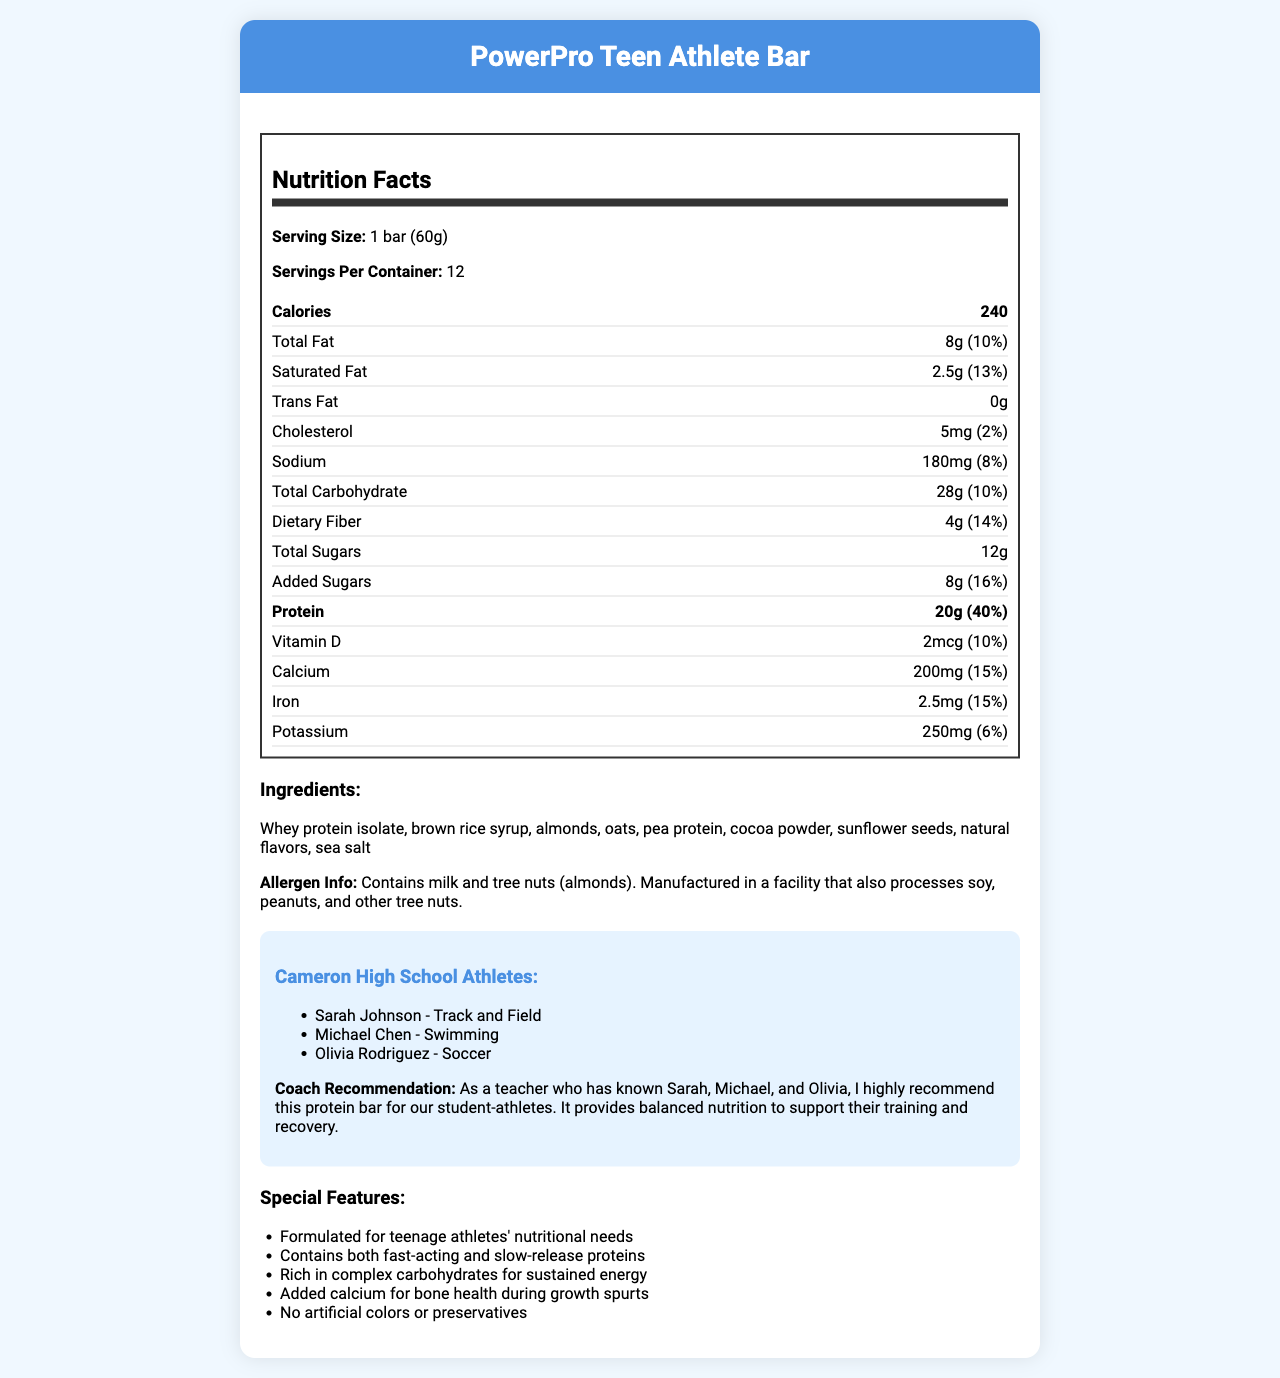what is the serving size of the PowerPro Teen Athlete Bar? The serving size is listed at the top of the nutrition label.
Answer: 1 bar (60g) how many calories are in one serving of the PowerPro Teen Athlete Bar? The calorie content per serving is mentioned directly in the Nutrition Facts section.
Answer: 240 how many grams of protein does the PowerPro Teen Athlete Bar contain? The protein content is specified in the nutrition facts under the section Protein.
Answer: 20g how many servings are in one container of the PowerPro Teen Athlete Bar? The servings per container information is provided at the beginning of the nutrition facts.
Answer: 12 name three camera high school athletes recommended for this protein bar? The names of the athletes are listed in the Cameron High School Athletes section.
Answer: Sarah Johnson, Michael Chen, Olivia Rodriguez what type of fats are included in the PowerPro Teen Athlete Bar? A. Trans Fat B. Saturated Fat C. Polyunsaturated Fat D. Monounsaturated Fat The nutrition facts show there are 2.5g of Saturated Fat and 0g of Trans Fat, clearly indicating the type of fat present.
Answer: B. Saturated Fat what is the daily value percentage for dietary fiber in the PowerPro Teen Athlete Bar? A. 10% B. 13% C. 14% D. 16% The daily value percentage for dietary fiber is indicated as 14% in the Nutrition Facts section.
Answer: C. 14% does the PowerPro Teen Athlete Bar contain any artificial colors or preservatives? One of the special features listed is that it contains no artificial colors or preservatives.
Answer: No does the PowerPro Teen Athlete Bar contain any allergens? The allergen information states that it contains milk and tree nuts (almonds) and is processed in a facility with other allergens.
Answer: Yes what are the main ingredients of the PowerPro Teen Athlete Bar? The ingredients list these main components clearly.
Answer: Whey protein isolate, brown rice syrup, almonds, oats, pea protein, cocoa powder, sunflower seeds, natural flavors, sea salt how much sodium is in each serving of the PowerPro Teen Athlete Bar? The amount of sodium per serving is listed in the nutrition facts.
Answer: 180mg what is the overall recommendation for the PowerPro Teen Athlete Bar based on the document? The Coach Recommendation section states a high recommendation for the student-athletes known to the teacher.
Answer: Highly recommended for student-athletes at Cameron High School can the manufacturing process of the PowerPro Teen Athlete Bar certify its safety for individuals with peanut allergies? The allergen info indicates it is processed in a facility with peanuts, but it doesn't provide details on the safety measures in place.
Answer: Not enough information what are some of the special features of the PowerPro Teen Athlete Bar? These features are explicitly listed under the Special Features section.
Answer: Formulated for teenage athletes' nutritional needs, Contains both fast-acting and slow-release proteins, Rich in complex carbohydrates for sustained energy, Added calcium for bone health during growth spurts, No artificial colors or preservatives summarize the main purpose of the document. This summary covers all key sections and main insights from the document, providing a comprehensive overview.
Answer: The document provides detailed nutritional information, ingredients, allergen information, special features, and recommendations for the PowerPro Teen Athlete Bar, which is a protein bar designed to meet the nutritional needs of teenage athletes. It emphasizes balanced nutrition, sustained energy, and support for bone health. 